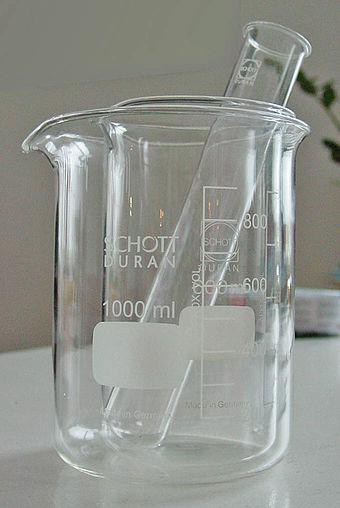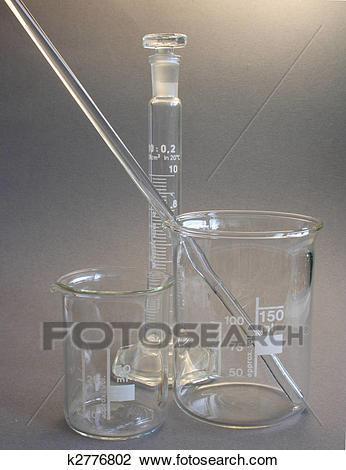The first image is the image on the left, the second image is the image on the right. Evaluate the accuracy of this statement regarding the images: "A long thin glass stick is in at least one beaker.". Is it true? Answer yes or no. Yes. 